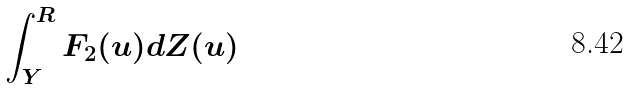Convert formula to latex. <formula><loc_0><loc_0><loc_500><loc_500>\int _ { Y } ^ { R } F _ { 2 } ( u ) d Z ( u )</formula> 